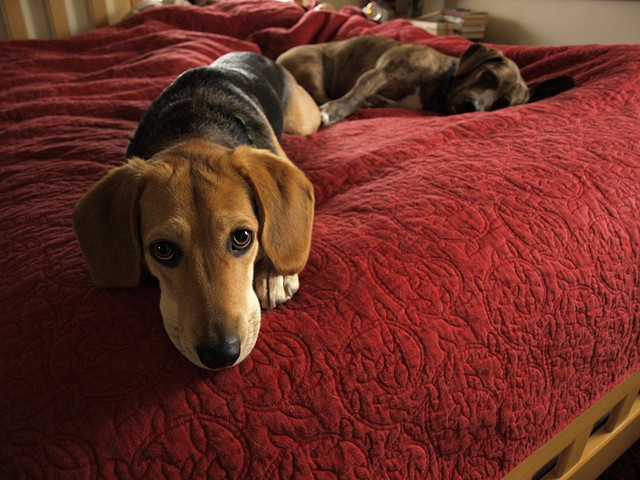Describe the objects in this image and their specific colors. I can see bed in maroon, black, and brown tones, dog in black, maroon, and brown tones, dog in black, maroon, and gray tones, book in black, brown, maroon, and gray tones, and book in black, maroon, darkgray, and gray tones in this image. 